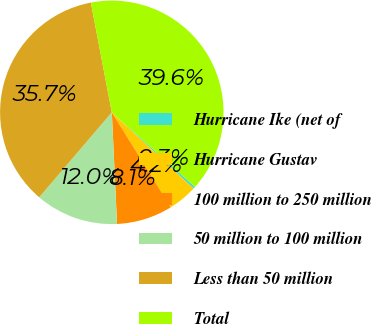Convert chart. <chart><loc_0><loc_0><loc_500><loc_500><pie_chart><fcel>Hurricane Ike (net of<fcel>Hurricane Gustav<fcel>100 million to 250 million<fcel>50 million to 100 million<fcel>Less than 50 million<fcel>Total<nl><fcel>0.32%<fcel>4.21%<fcel>8.1%<fcel>12.0%<fcel>35.74%<fcel>39.63%<nl></chart> 